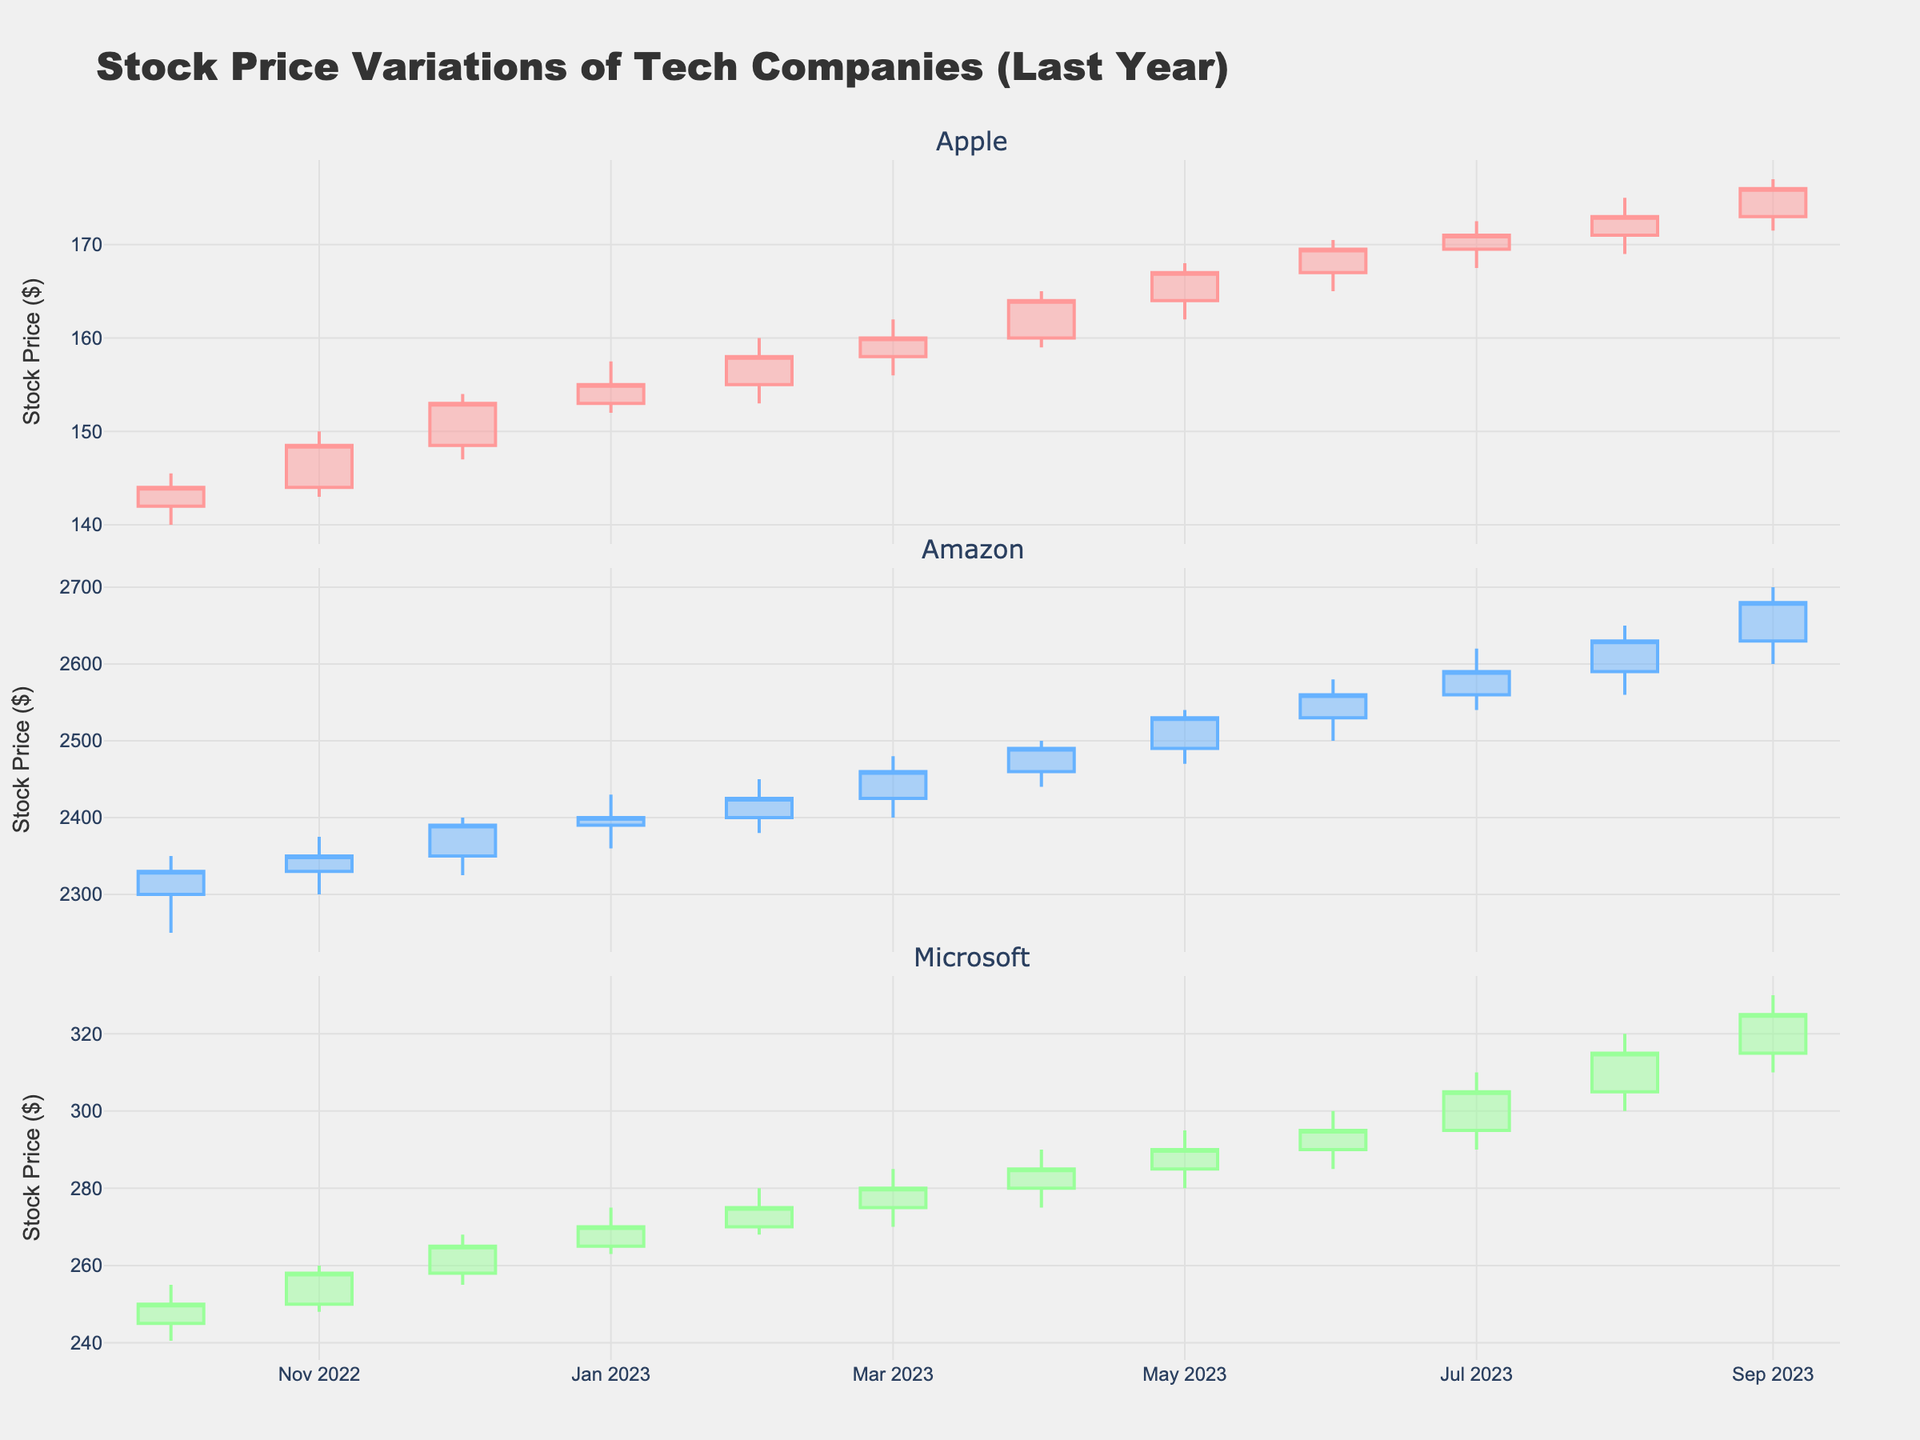What is the title of the plot? The title is usually displayed prominently at the top of the plot. In this case, look for the largest text, typically in bold, at the top.
Answer: Stock Price Variations of Tech Companies (Last Year) Which company showed the highest stock price in August 2023? Identify the candlestick for August 2023 in each subplot. Compare the high values of each candlestick.
Answer: Amazon What is the color of the increasing candlesticks for Apple? Look for the color of the candlesticks that show increasing stock prices in the Apple subplot.
Answer: Red Which company's stock had the highest closing price in the last month shown on the plot? Look at the closing prices (the right edges of the candlesticks) for the last month in each subplot and compare them.
Answer: Amazon How did Apple's stock price change from February 2023 to March 2023? Check the closing prices for February and March in the Apple subplot and calculate the difference.
Answer: Increased Which company had the largest range in its stock price in July 2023? For July 2023, find the difference between the high and low prices for each company and compare the ranges.
Answer: Microsoft What was the lowest stock price for Microsoft throughout the entire period? Identify the lowest points of the candlesticks over all the months in the Microsoft subplot.
Answer: $240.50 Compare the trading volume of Amazon and Microsoft in May 2023. Look for the data points indicating trading volume for both companies in May and compare them.
Answer: Amazon has lower volume What is the average closing price of Apple's stock over the period shown in the plot? Sum up the closing prices for each month for Apple and divide by the number of months.
Answer: $162.12 Did all three companies’ stocks generally increase, decrease, or remain stable over the last year? Observe the trend lines formed by the closing prices from the start to the end of the period for all three companies.
Answer: Increase 